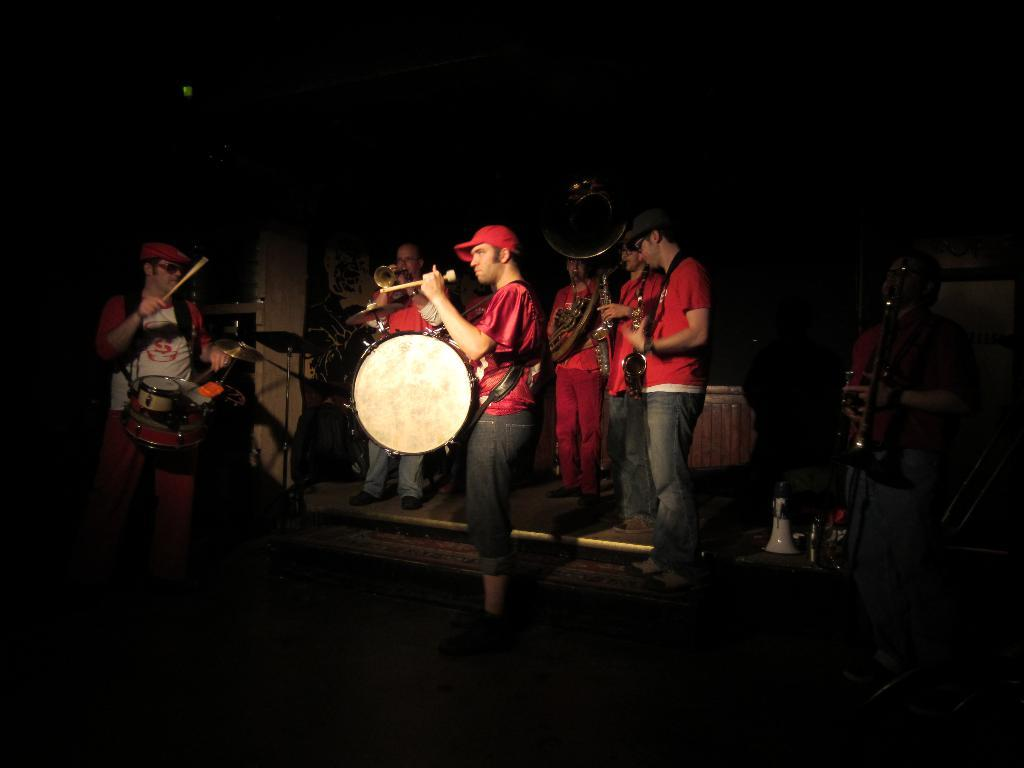How many persons are in the image? There is a group of persons in the image. What are the persons in the image doing? The persons are standing in the image and playing musical instruments. What type of humor can be seen on the table in the image? There is no table or humor present in the image. Where is the bedroom located in the image? There is no bedroom present in the image. 